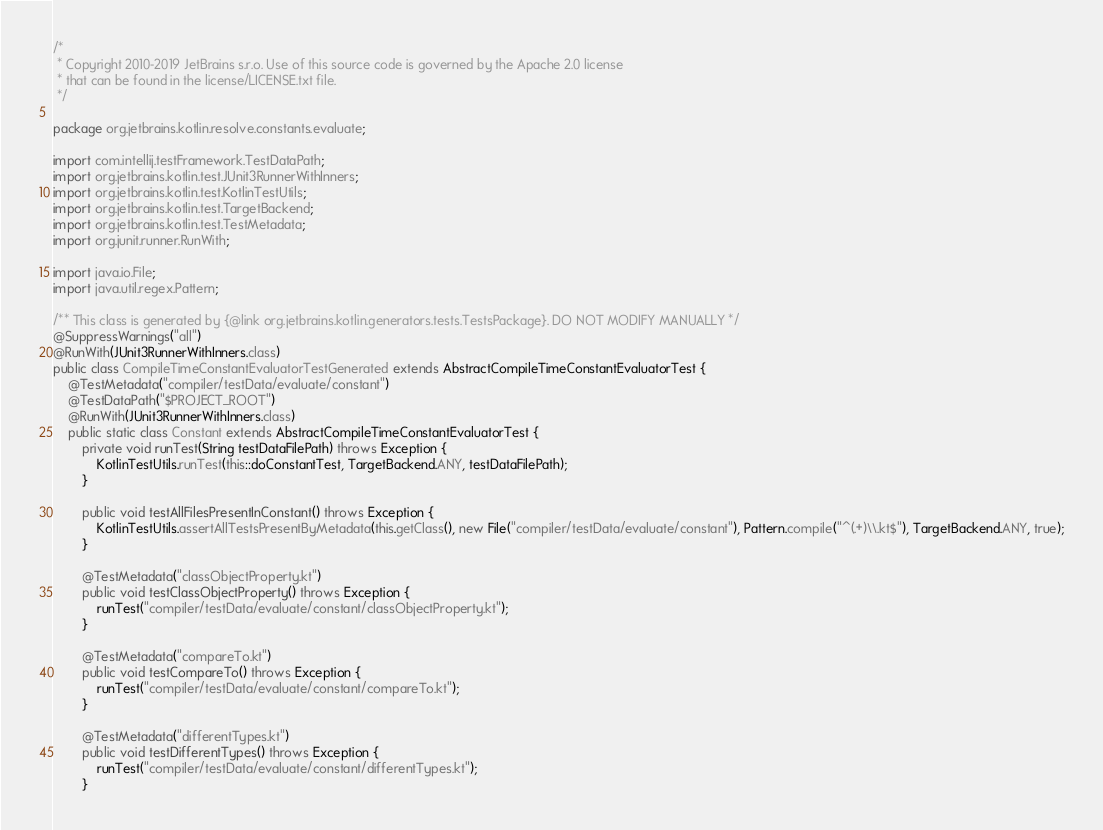<code> <loc_0><loc_0><loc_500><loc_500><_Java_>/*
 * Copyright 2010-2019 JetBrains s.r.o. Use of this source code is governed by the Apache 2.0 license
 * that can be found in the license/LICENSE.txt file.
 */

package org.jetbrains.kotlin.resolve.constants.evaluate;

import com.intellij.testFramework.TestDataPath;
import org.jetbrains.kotlin.test.JUnit3RunnerWithInners;
import org.jetbrains.kotlin.test.KotlinTestUtils;
import org.jetbrains.kotlin.test.TargetBackend;
import org.jetbrains.kotlin.test.TestMetadata;
import org.junit.runner.RunWith;

import java.io.File;
import java.util.regex.Pattern;

/** This class is generated by {@link org.jetbrains.kotlin.generators.tests.TestsPackage}. DO NOT MODIFY MANUALLY */
@SuppressWarnings("all")
@RunWith(JUnit3RunnerWithInners.class)
public class CompileTimeConstantEvaluatorTestGenerated extends AbstractCompileTimeConstantEvaluatorTest {
    @TestMetadata("compiler/testData/evaluate/constant")
    @TestDataPath("$PROJECT_ROOT")
    @RunWith(JUnit3RunnerWithInners.class)
    public static class Constant extends AbstractCompileTimeConstantEvaluatorTest {
        private void runTest(String testDataFilePath) throws Exception {
            KotlinTestUtils.runTest(this::doConstantTest, TargetBackend.ANY, testDataFilePath);
        }

        public void testAllFilesPresentInConstant() throws Exception {
            KotlinTestUtils.assertAllTestsPresentByMetadata(this.getClass(), new File("compiler/testData/evaluate/constant"), Pattern.compile("^(.+)\\.kt$"), TargetBackend.ANY, true);
        }

        @TestMetadata("classObjectProperty.kt")
        public void testClassObjectProperty() throws Exception {
            runTest("compiler/testData/evaluate/constant/classObjectProperty.kt");
        }

        @TestMetadata("compareTo.kt")
        public void testCompareTo() throws Exception {
            runTest("compiler/testData/evaluate/constant/compareTo.kt");
        }

        @TestMetadata("differentTypes.kt")
        public void testDifferentTypes() throws Exception {
            runTest("compiler/testData/evaluate/constant/differentTypes.kt");
        }
</code> 